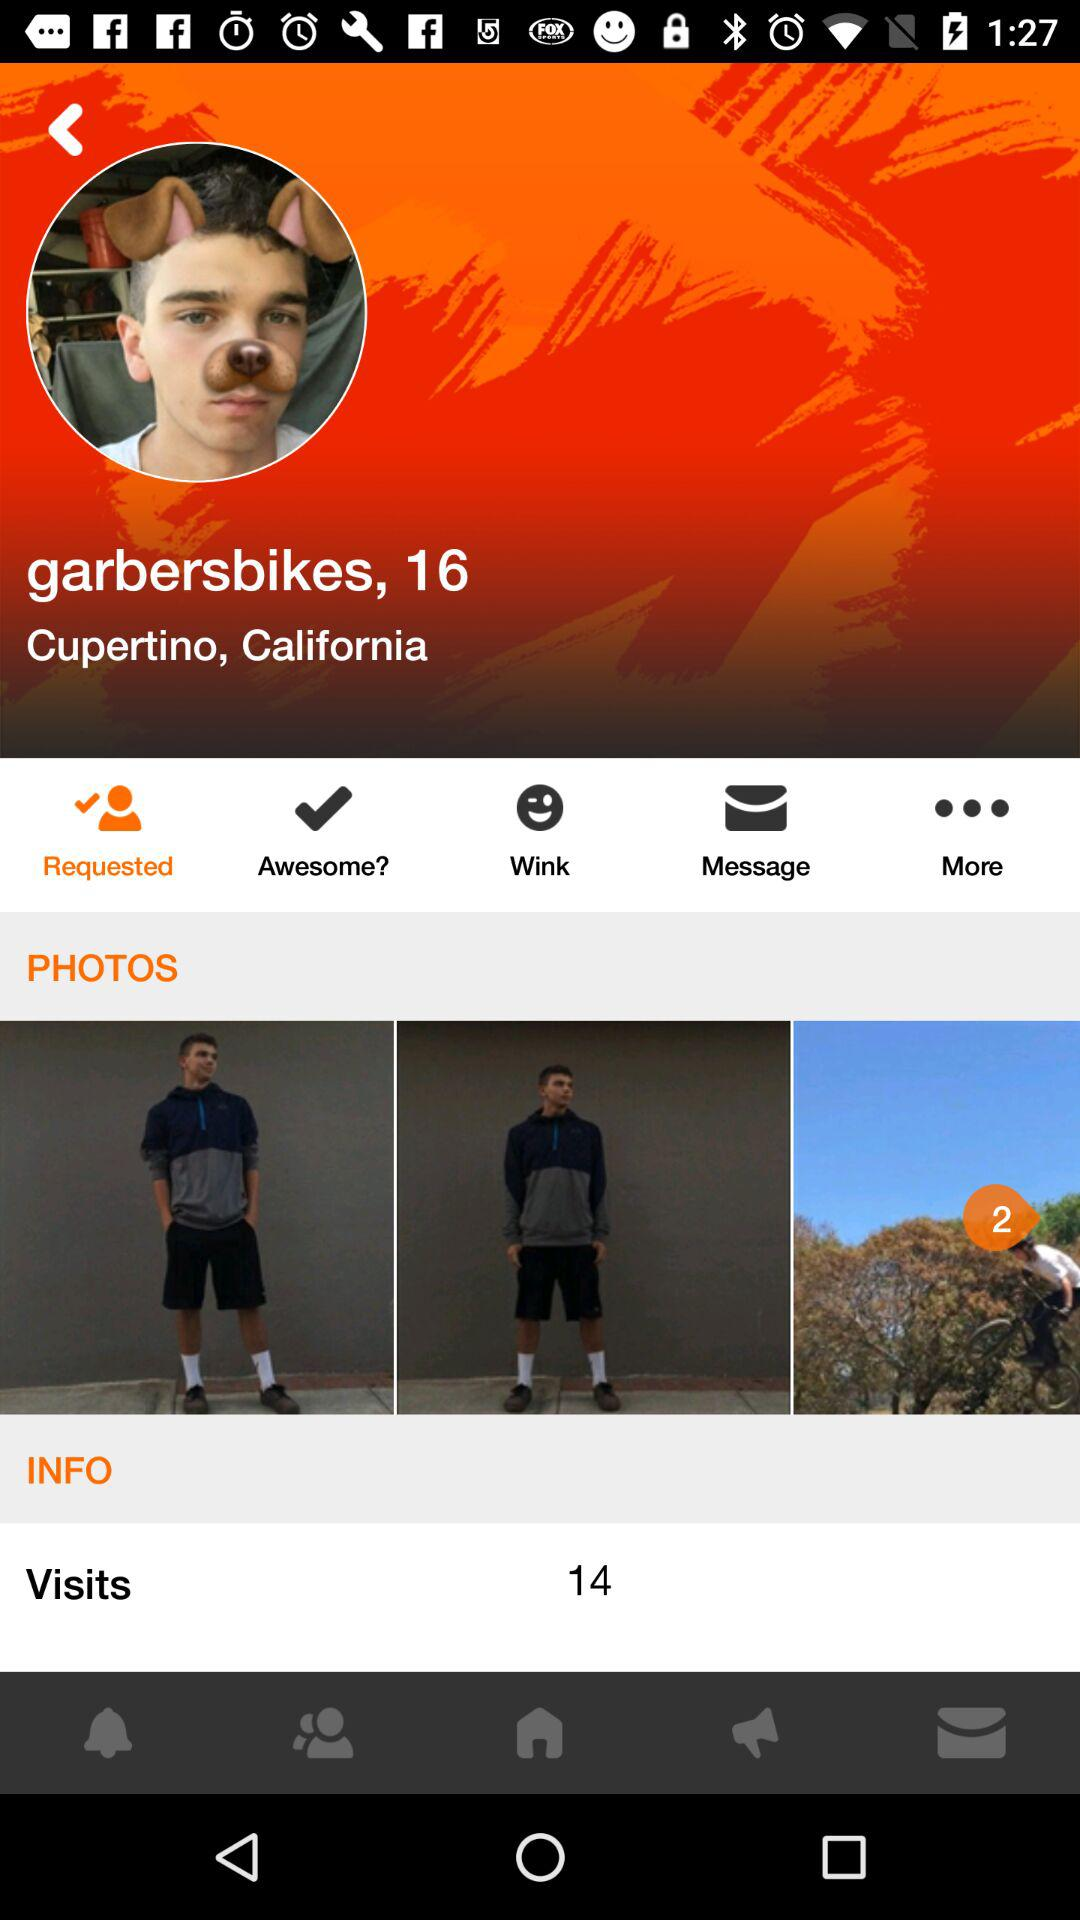How many photos are of the man wearing a gray sweatshirt and black shorts?
Answer the question using a single word or phrase. 2 